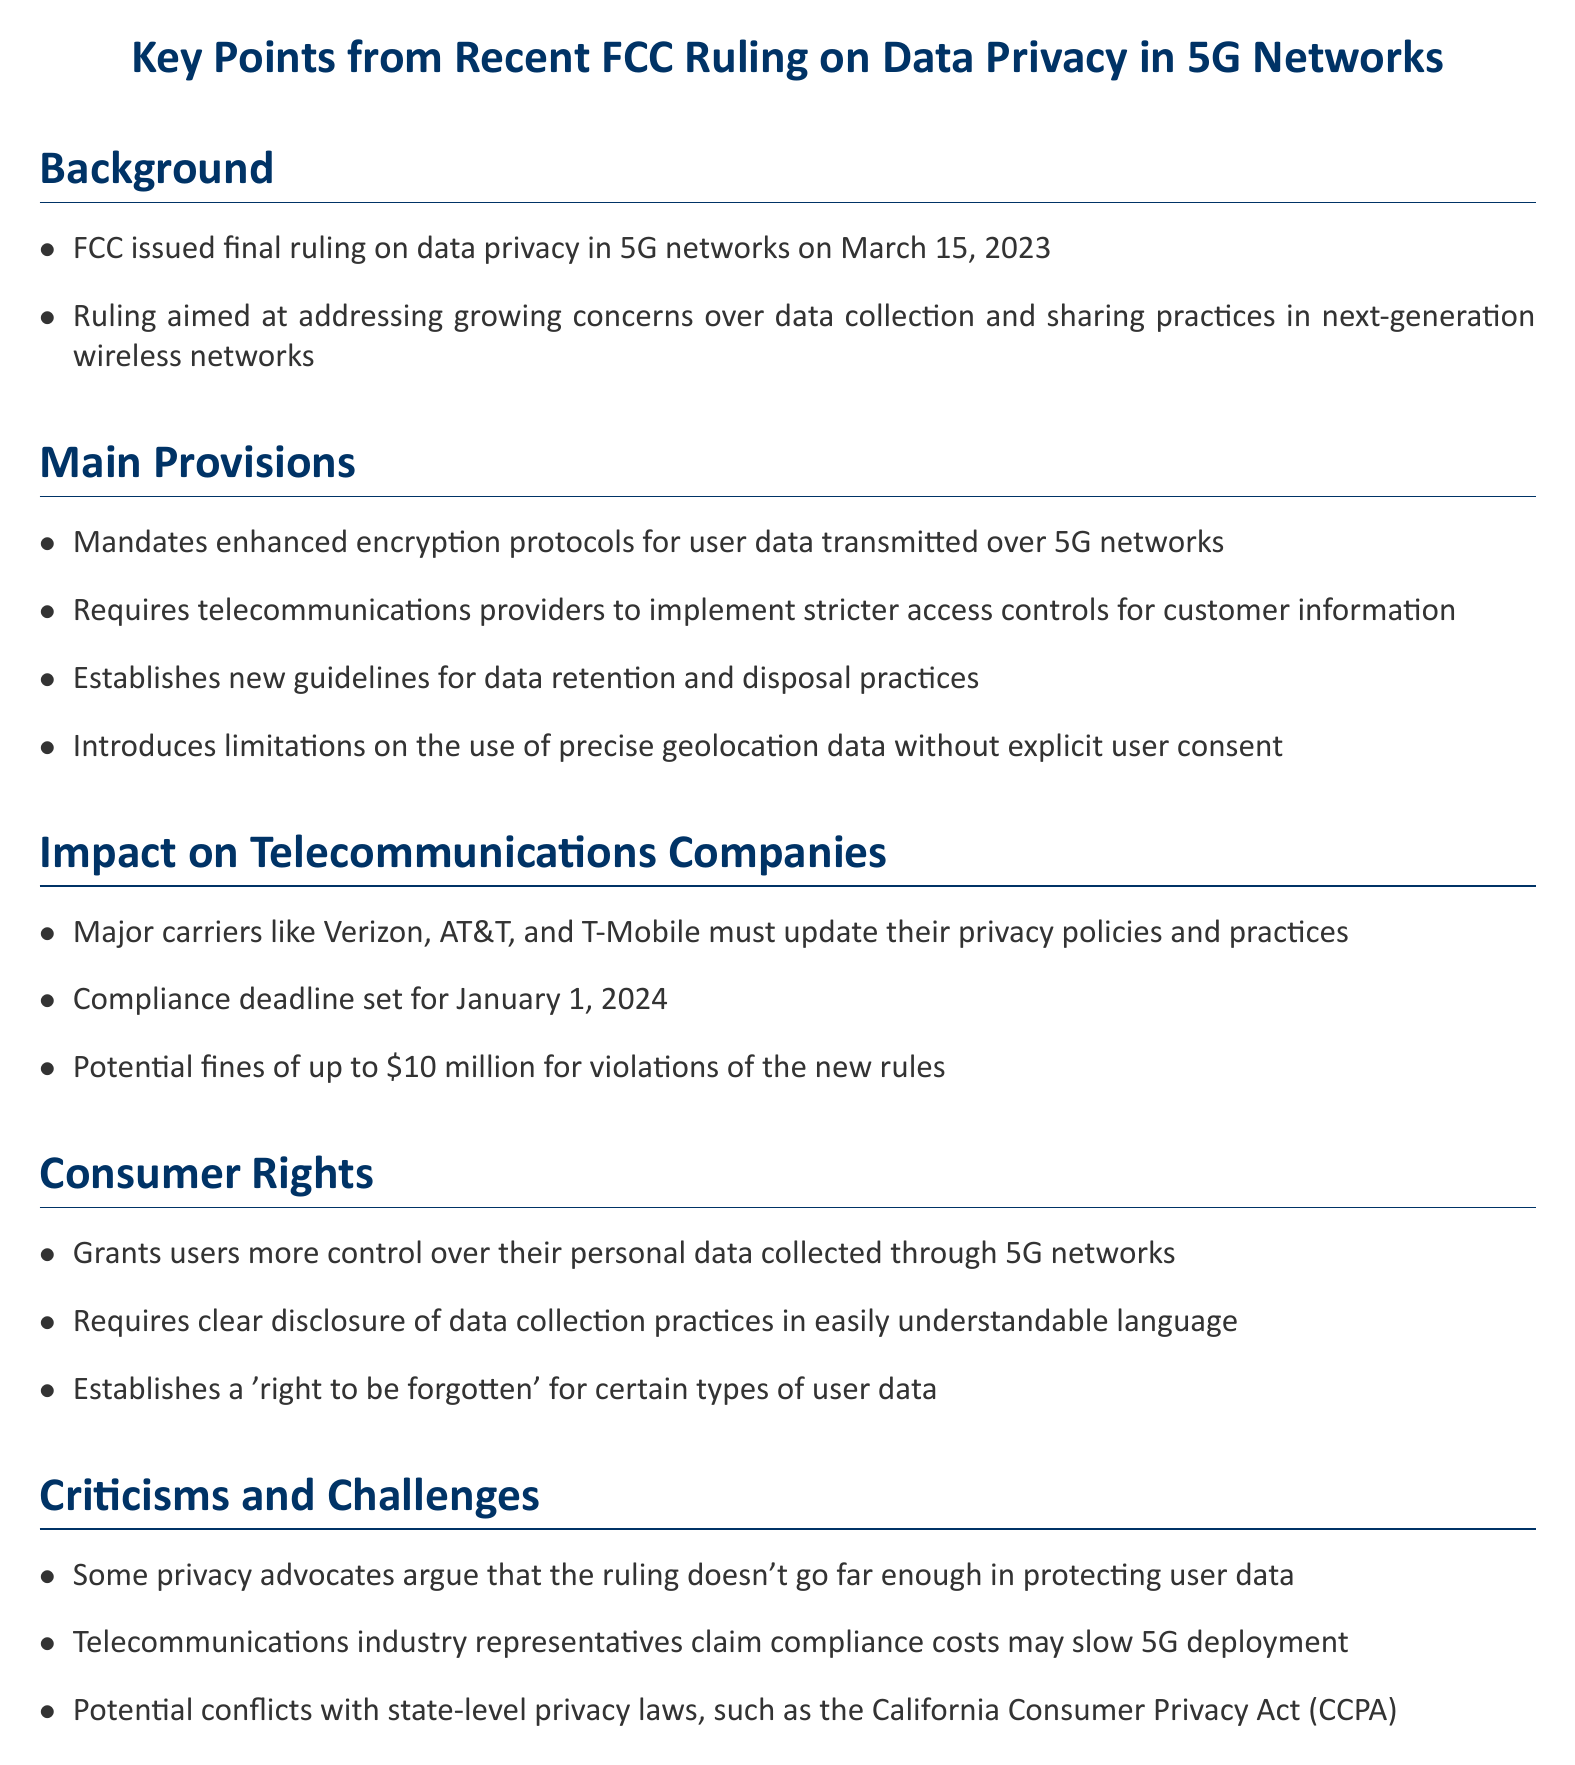What date was the FCC ruling issued? The document states the final ruling date, which is March 15, 2023.
Answer: March 15, 2023 What are the potential fines for violations of the new rules? The document mentions the specific amount that can be fined for violations, which is up to $10 million.
Answer: $10 million Who are the major telecommunications companies affected by the ruling? The document lists the major carriers required to update their privacy policies, including Verizon, AT&T, and T-Mobile.
Answer: Verizon, AT&T, T-Mobile What is the compliance deadline for telecommunications providers? The document specifies the deadline for compliance, which is January 1, 2024.
Answer: January 1, 2024 What new consumer right is established in the ruling? The document states that a 'right to be forgotten' is established for certain user data types.
Answer: Right to be forgotten What is one criticism mentioned about the FCC ruling? The document notes that some privacy advocates believe the ruling does not adequately protect user data.
Answer: Doesn't go far enough What do telecommunications representatives claim regarding compliance costs? The document indicates that industry representatives claim these costs may slow down 5G deployment.
Answer: May slow 5G deployment What does the ruling mandate regarding user data encryption? The document describes the requirement for encryption protocols, specifically enhanced protocols for user data.
Answer: Enhanced encryption protocols 